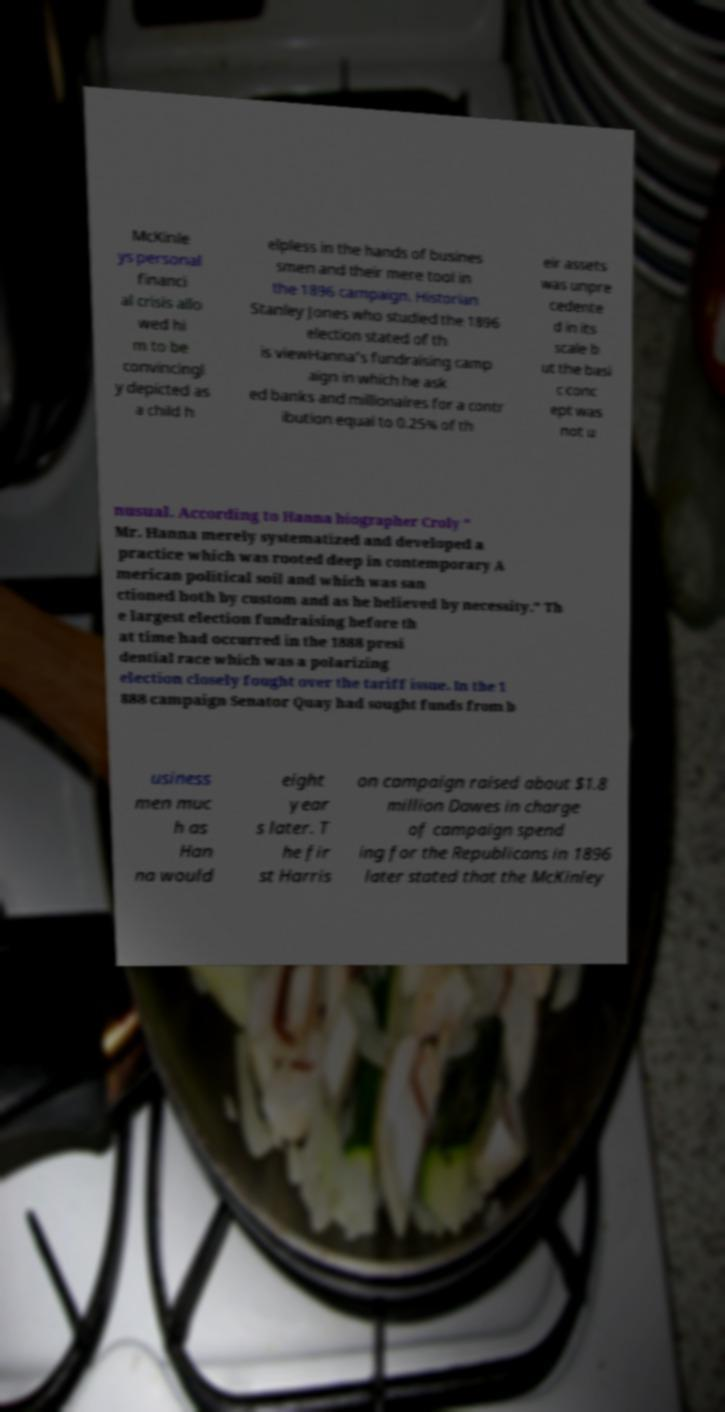Can you read and provide the text displayed in the image?This photo seems to have some interesting text. Can you extract and type it out for me? McKinle ys personal financi al crisis allo wed hi m to be convincingl y depicted as a child h elpless in the hands of busines smen and their mere tool in the 1896 campaign. Historian Stanley Jones who studied the 1896 election stated of th is viewHanna's fundraising camp aign in which he ask ed banks and millionaires for a contr ibution equal to 0.25% of th eir assets was unpre cedente d in its scale b ut the basi c conc ept was not u nusual. According to Hanna biographer Croly " Mr. Hanna merely systematized and developed a practice which was rooted deep in contemporary A merican political soil and which was san ctioned both by custom and as he believed by necessity." Th e largest election fundraising before th at time had occurred in the 1888 presi dential race which was a polarizing election closely fought over the tariff issue. In the 1 888 campaign Senator Quay had sought funds from b usiness men muc h as Han na would eight year s later. T he fir st Harris on campaign raised about $1.8 million Dawes in charge of campaign spend ing for the Republicans in 1896 later stated that the McKinley 